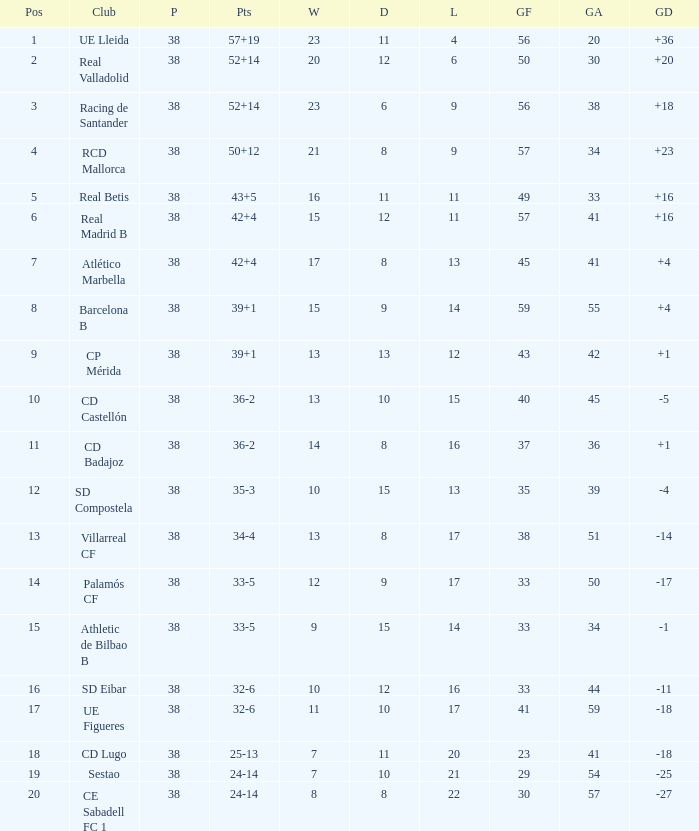What is the highest number played with a goal difference less than -27? None. 